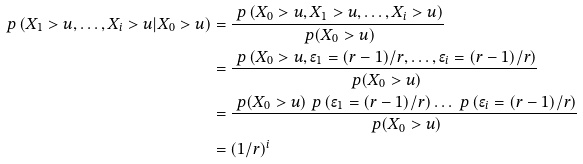Convert formula to latex. <formula><loc_0><loc_0><loc_500><loc_500>\ p \left ( X _ { 1 } > u , \dots , X _ { i } > u | X _ { 0 } > u \right ) & = \frac { \ p \left ( X _ { 0 } > u , X _ { 1 } > u , \dots , X _ { i } > u \right ) } { \ p ( X _ { 0 } > u ) } \\ & = \frac { \ p \left ( X _ { 0 } > u , \epsilon _ { 1 } = ( r - 1 ) / r , \dots , \epsilon _ { i } = ( r - 1 ) / r \right ) } { \ p ( X _ { 0 } > u ) } \\ & = \frac { \ p ( X _ { 0 } > u ) \ p \left ( \epsilon _ { 1 } = ( r - 1 ) / r \right ) \dots \ p \left ( \epsilon _ { i } = ( r - 1 ) / r \right ) } { \ p ( X _ { 0 } > u ) } \\ & = ( 1 / r ) ^ { i }</formula> 